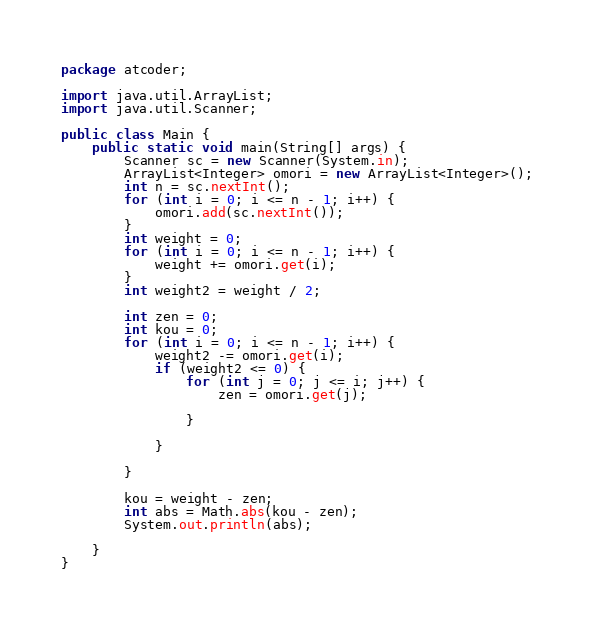<code> <loc_0><loc_0><loc_500><loc_500><_Java_>package atcoder;

import java.util.ArrayList;
import java.util.Scanner;

public class Main {
	public static void main(String[] args) {
		Scanner sc = new Scanner(System.in);
		ArrayList<Integer> omori = new ArrayList<Integer>();
		int n = sc.nextInt();
		for (int i = 0; i <= n - 1; i++) {
			omori.add(sc.nextInt());
		}
		int weight = 0;
		for (int i = 0; i <= n - 1; i++) {
			weight += omori.get(i);
		}
		int weight2 = weight / 2;

		int zen = 0;
		int kou = 0;
		for (int i = 0; i <= n - 1; i++) {
			weight2 -= omori.get(i);
			if (weight2 <= 0) {
				for (int j = 0; j <= i; j++) {
					zen = omori.get(j);

				}

			}

		}

		kou = weight - zen;
		int abs = Math.abs(kou - zen);
		System.out.println(abs);

	}
}
</code> 